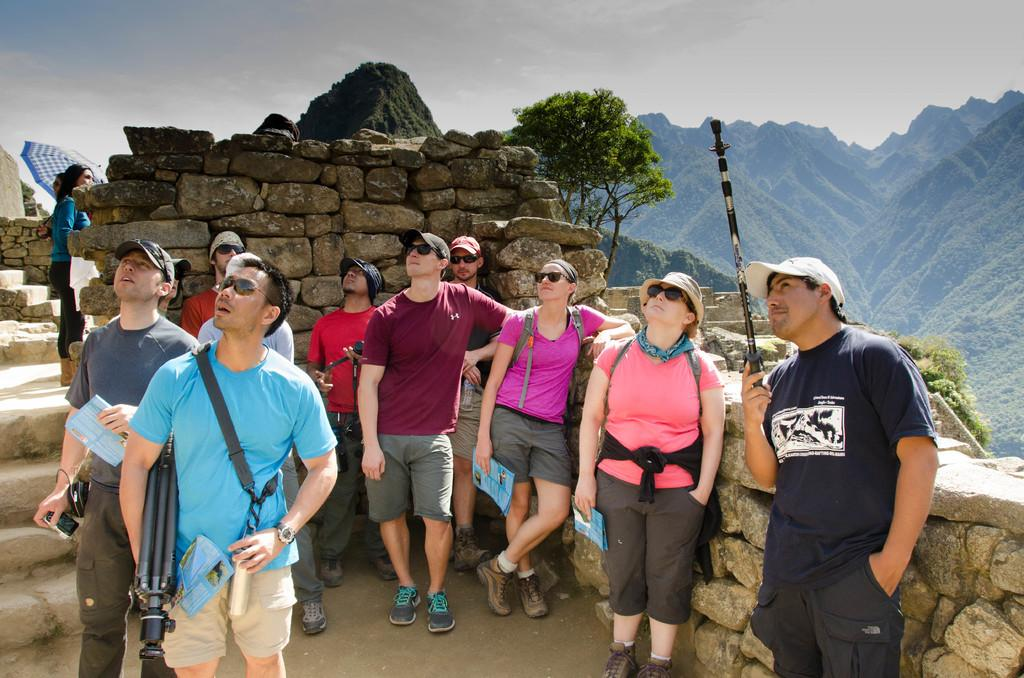How many persons can be seen in the center of the image? There are many persons standing in the center of the image. What is the surface on which the persons are standing? The persons are standing on the ground. What can be seen in the background of the image? In the background, there are bricks, a person holding an umbrella, a fort, hills, and the sky. What is the condition of the sky in the image? The sky is visible in the background, and clouds are present. What is the condition of the person's throat in the image? There is no information about the person's throat in the image, as the focus is on the group of persons and the background elements. 